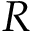<formula> <loc_0><loc_0><loc_500><loc_500>R</formula> 